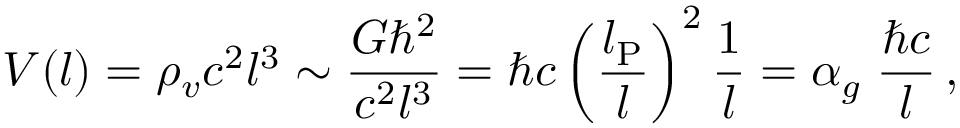<formula> <loc_0><loc_0><loc_500><loc_500>V ( l ) = \rho _ { v } c ^ { 2 } l ^ { 3 } \sim \frac { G \hbar { ^ } { 2 } } { c ^ { 2 } l ^ { 3 } } = \hbar { c } \left ( \frac { l _ { P } } { l } \right ) ^ { 2 } \frac { 1 } { l } = \alpha _ { g } \, \frac { \hbar { c } } { l } \, ,</formula> 